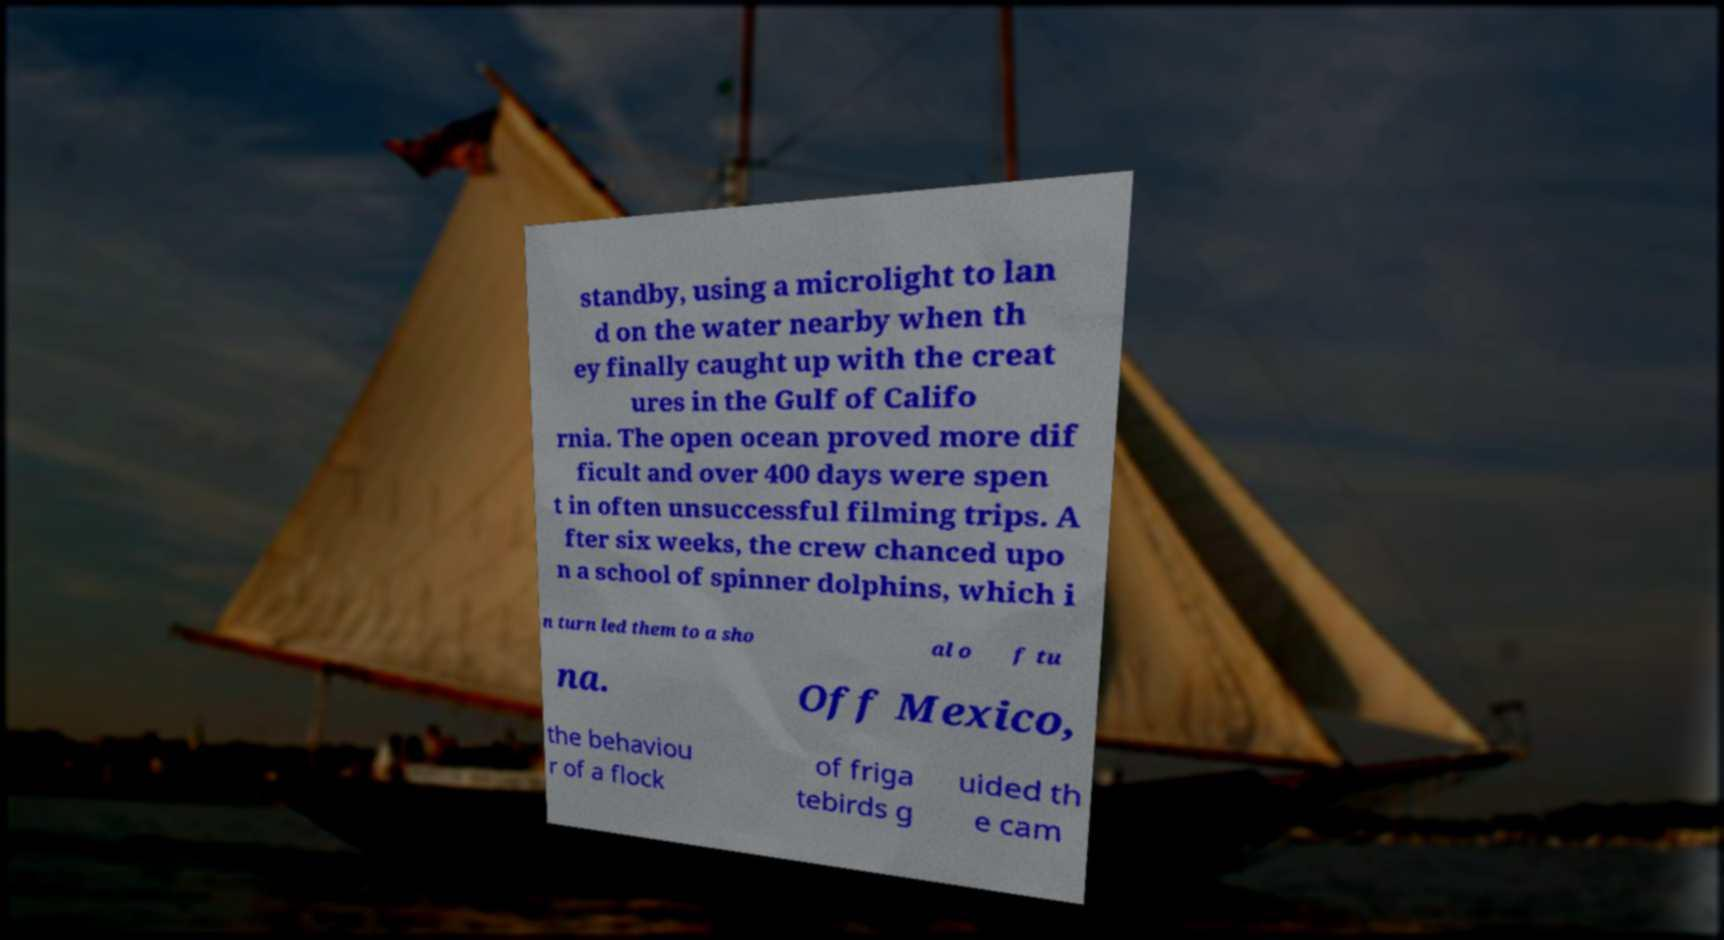There's text embedded in this image that I need extracted. Can you transcribe it verbatim? standby, using a microlight to lan d on the water nearby when th ey finally caught up with the creat ures in the Gulf of Califo rnia. The open ocean proved more dif ficult and over 400 days were spen t in often unsuccessful filming trips. A fter six weeks, the crew chanced upo n a school of spinner dolphins, which i n turn led them to a sho al o f tu na. Off Mexico, the behaviou r of a flock of friga tebirds g uided th e cam 